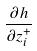<formula> <loc_0><loc_0><loc_500><loc_500>\frac { \partial h } { \partial z _ { i } ^ { + } }</formula> 